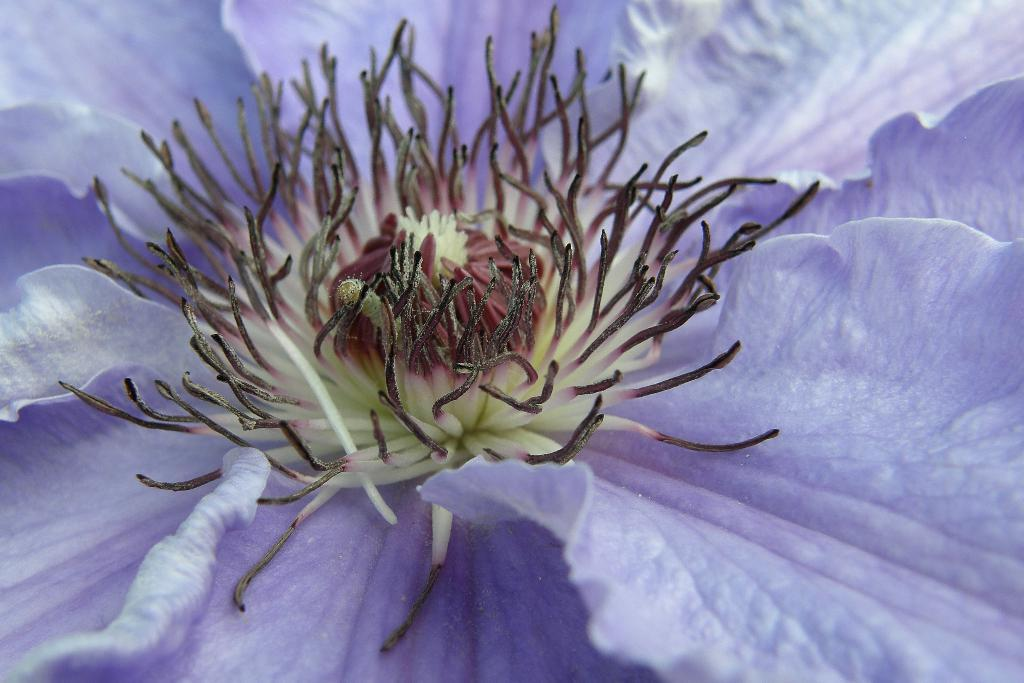What is the main subject of the image? There is a flower in the image. What type of net is used to hold the money in the image? There is no net or money present in the image; it features a flower. How many zippers can be seen on the flower in the image? There are no zippers on the flower in the image, as zippers are not a part of a flower's structure. 